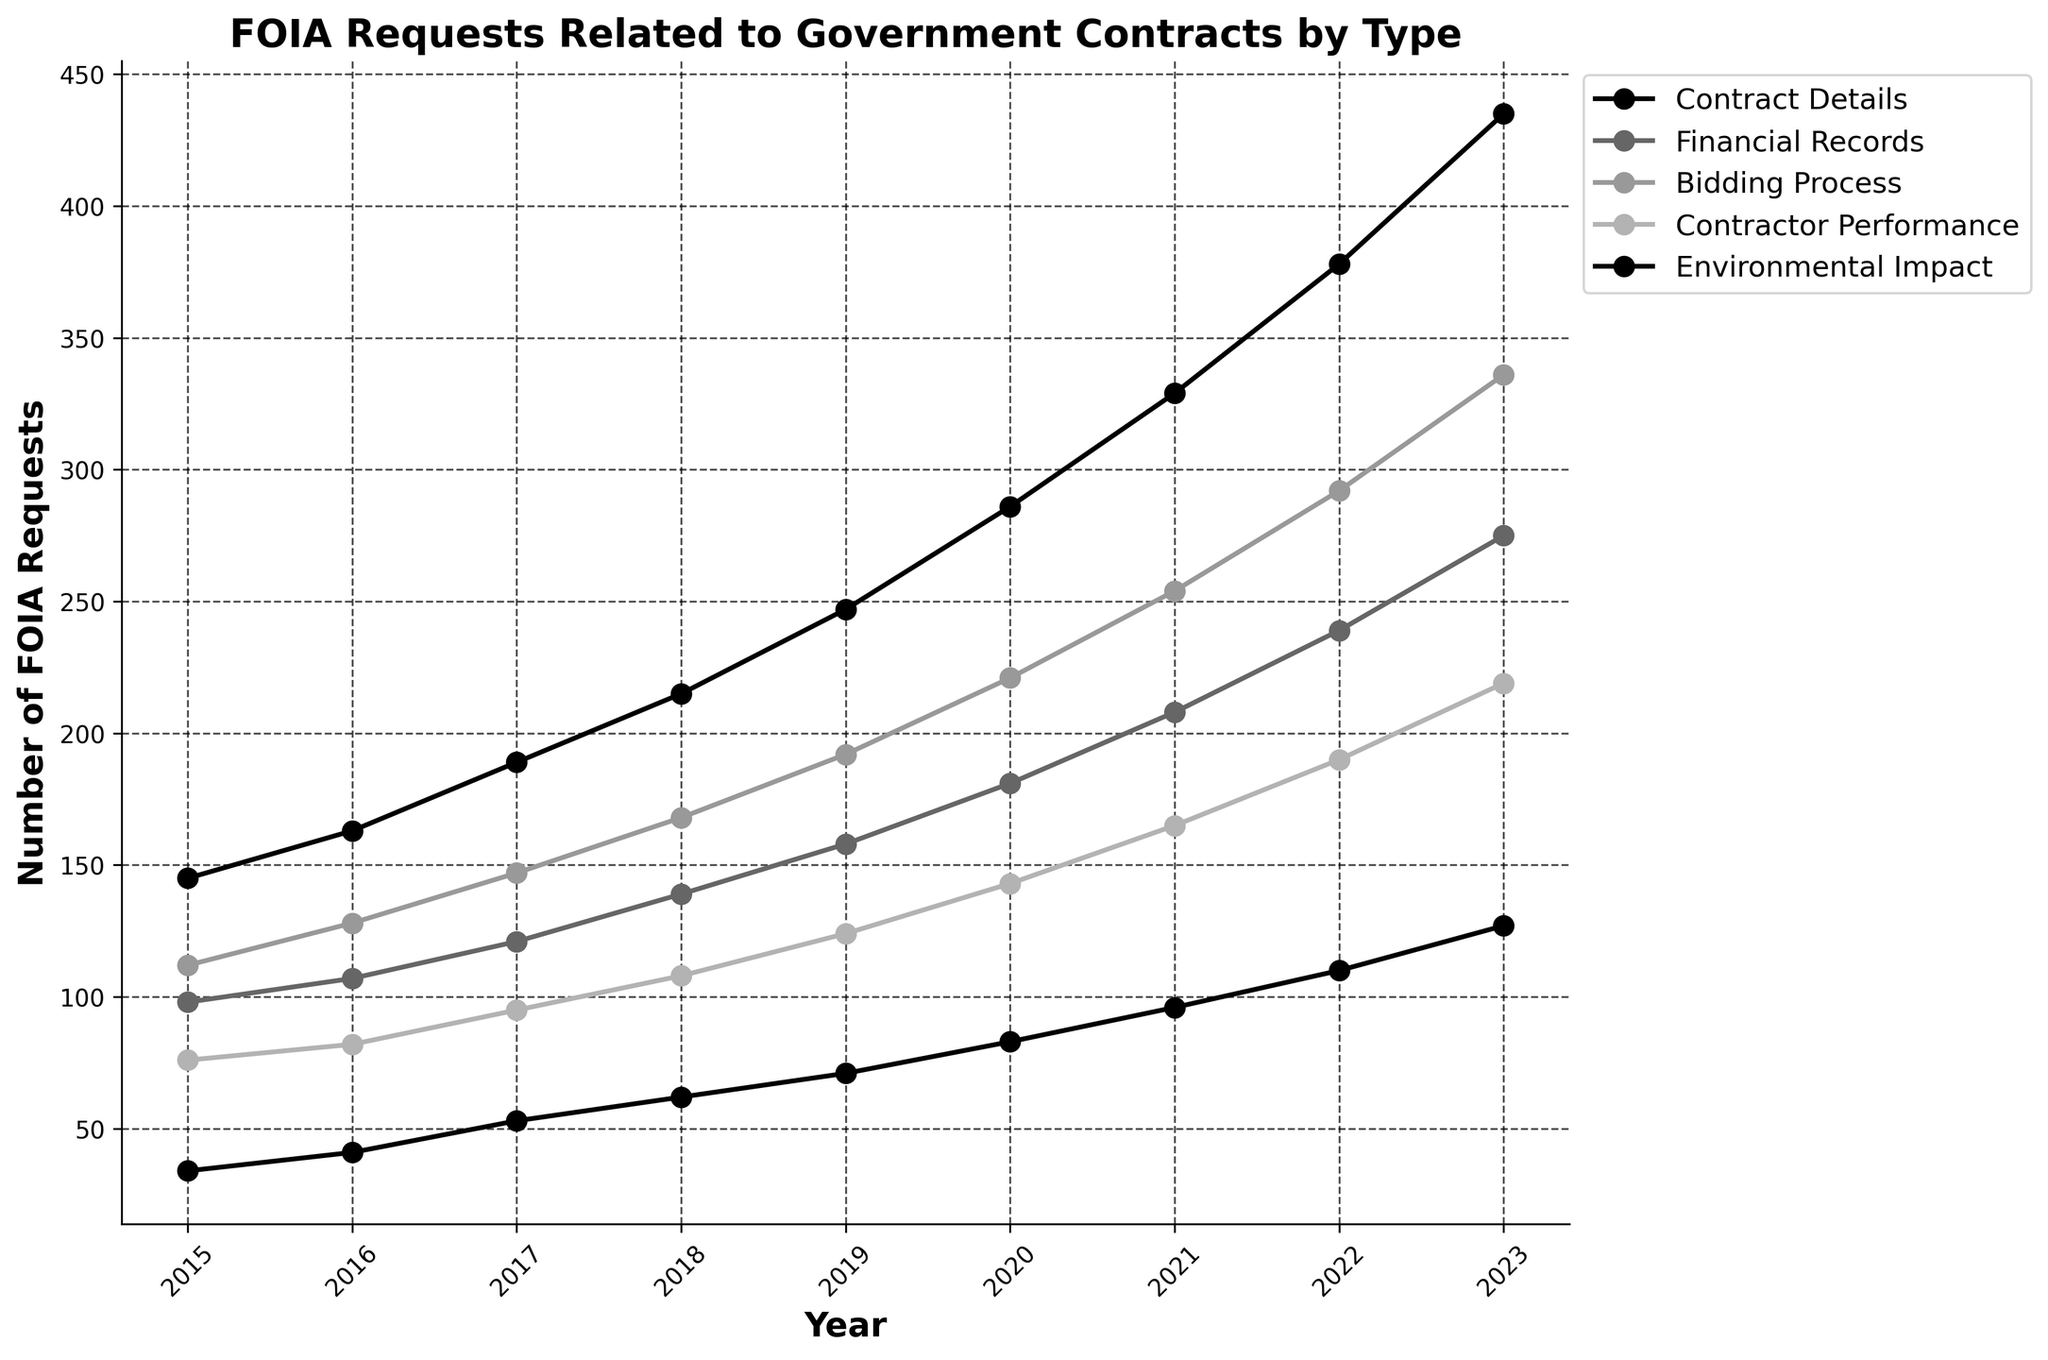What's the trend in the number of FOIA requests for Financial Records from 2015 to 2023? Visualize the curve for Financial Records from 2015 to 2023 to observe the overall direction. The count increases every year starting from 98 in 2015 to 275 in 2023.
Answer: Increasing Which category had the highest number of FOIA requests in 2023? Refer to the data values or height of the lines in 2023. The category with the highest number of FOIA requests in 2023 is "Contract Details" with 435 requests.
Answer: Contract Details Between which consecutive years did the Contractor Performance FOIA requests increase the most? Compare the year-over-year increases in the Contractor Performance line. The largest increase is between 2022 and 2023, rising from 190 to 219 (an increase of 29).
Answer: 2022-2023 In which year did the total number of FOIA requests for all categories first exceed 900? Calculate the sums of FOIA requests for each year and identify when it exceeded 900. 2020 is the first year with 914 requests (286 + 181 + 221 + 143 + 83 = 914).
Answer: 2020 How much did the number of FOIA requests for Environmental Impact grow from 2015 to 2023? Subtract the 2015 value from the 2023 value for Environmental Impact. This category grew from 34 in 2015 to 127 in 2023. Calculating the difference: 127 - 34 = 93.
Answer: 93 Compared to 2019, did the number of FOIA requests for Bidding Process in 2021 increase or decrease, and by how much? Check the values for Bidding Process in 2019 and 2021. In 2019, there were 192 requests and in 2021, there were 254. The increase is 254 - 192 = 62.
Answer: Increase, 62 What's the average number of FOIA requests for Contractor Performance from 2015 to 2023? Add the values for Contractor Performance from 2015 to 2023 and divide by the number of years (9). The sum is: 76 + 82 + 95 + 108 + 124 + 143 + 165 + 190 + 219 = 1202. Average = 1202 / 9 ≈ 133.56.
Answer: 133.56 Is the increase in FOIA requests for Contract Details between 2018 and 2021 greater than the increase between 2021 and 2023? Calculate both increments: for 2018-2021, the increase is from 215 to 329 (329 - 215 = 114). For 2021-2023, the increase is from 329 to 435 (435 - 329 = 106).
Answer: Yes 